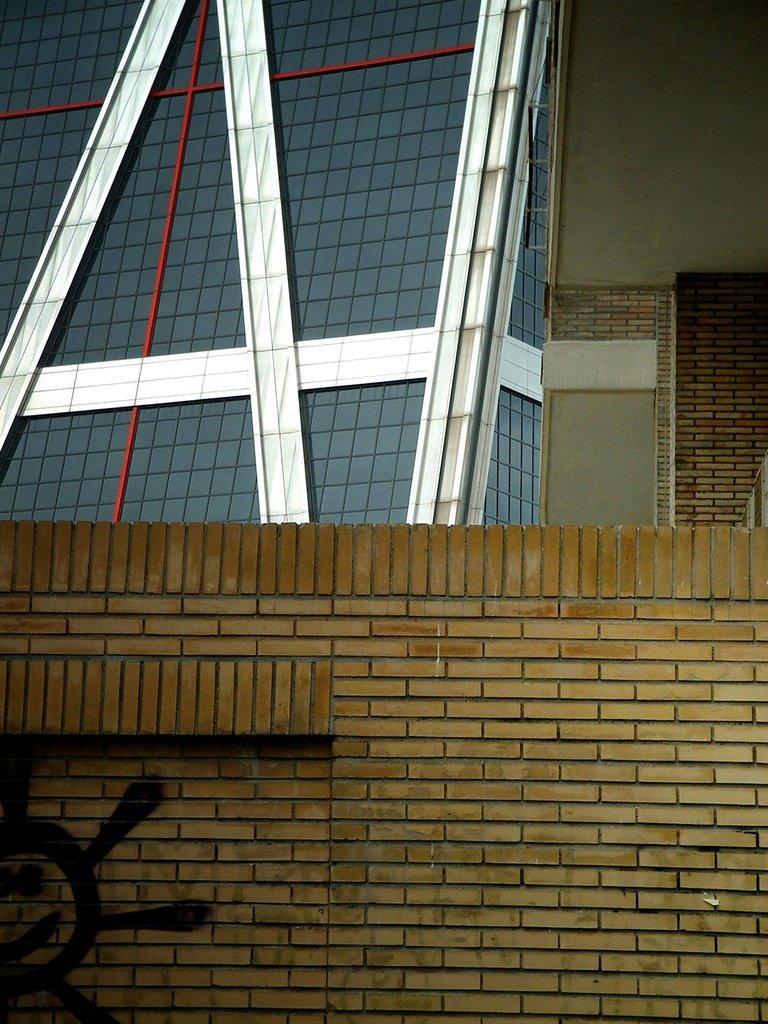Please provide a concise description of this image. This is a wall in the down side. 